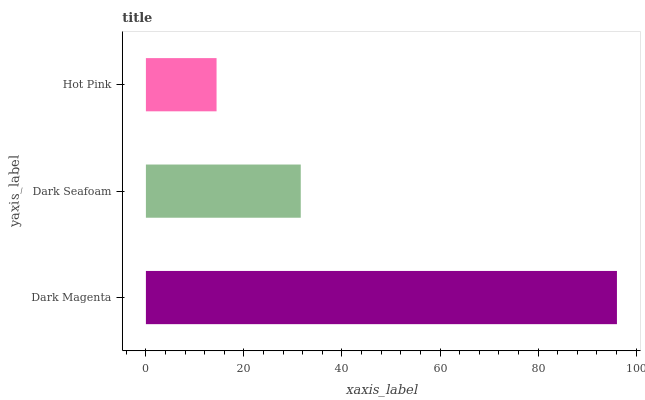Is Hot Pink the minimum?
Answer yes or no. Yes. Is Dark Magenta the maximum?
Answer yes or no. Yes. Is Dark Seafoam the minimum?
Answer yes or no. No. Is Dark Seafoam the maximum?
Answer yes or no. No. Is Dark Magenta greater than Dark Seafoam?
Answer yes or no. Yes. Is Dark Seafoam less than Dark Magenta?
Answer yes or no. Yes. Is Dark Seafoam greater than Dark Magenta?
Answer yes or no. No. Is Dark Magenta less than Dark Seafoam?
Answer yes or no. No. Is Dark Seafoam the high median?
Answer yes or no. Yes. Is Dark Seafoam the low median?
Answer yes or no. Yes. Is Hot Pink the high median?
Answer yes or no. No. Is Dark Magenta the low median?
Answer yes or no. No. 